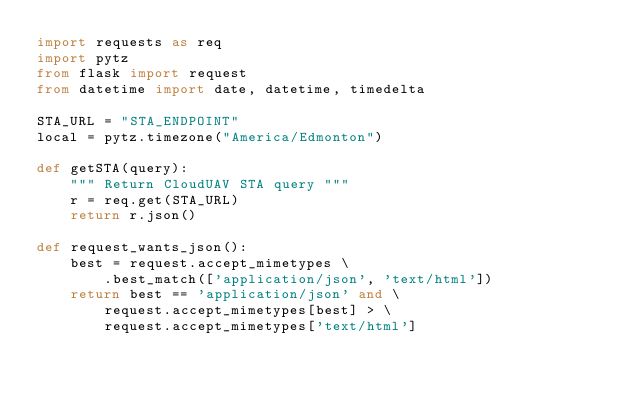Convert code to text. <code><loc_0><loc_0><loc_500><loc_500><_Python_>import requests as req
import pytz
from flask import request
from datetime import date, datetime, timedelta

STA_URL = "STA_ENDPOINT"
local = pytz.timezone("America/Edmonton")

def getSTA(query):
    """ Return CloudUAV STA query """
    r = req.get(STA_URL)
    return r.json()

def request_wants_json():
    best = request.accept_mimetypes \
        .best_match(['application/json', 'text/html'])
    return best == 'application/json' and \
        request.accept_mimetypes[best] > \
        request.accept_mimetypes['text/html']</code> 